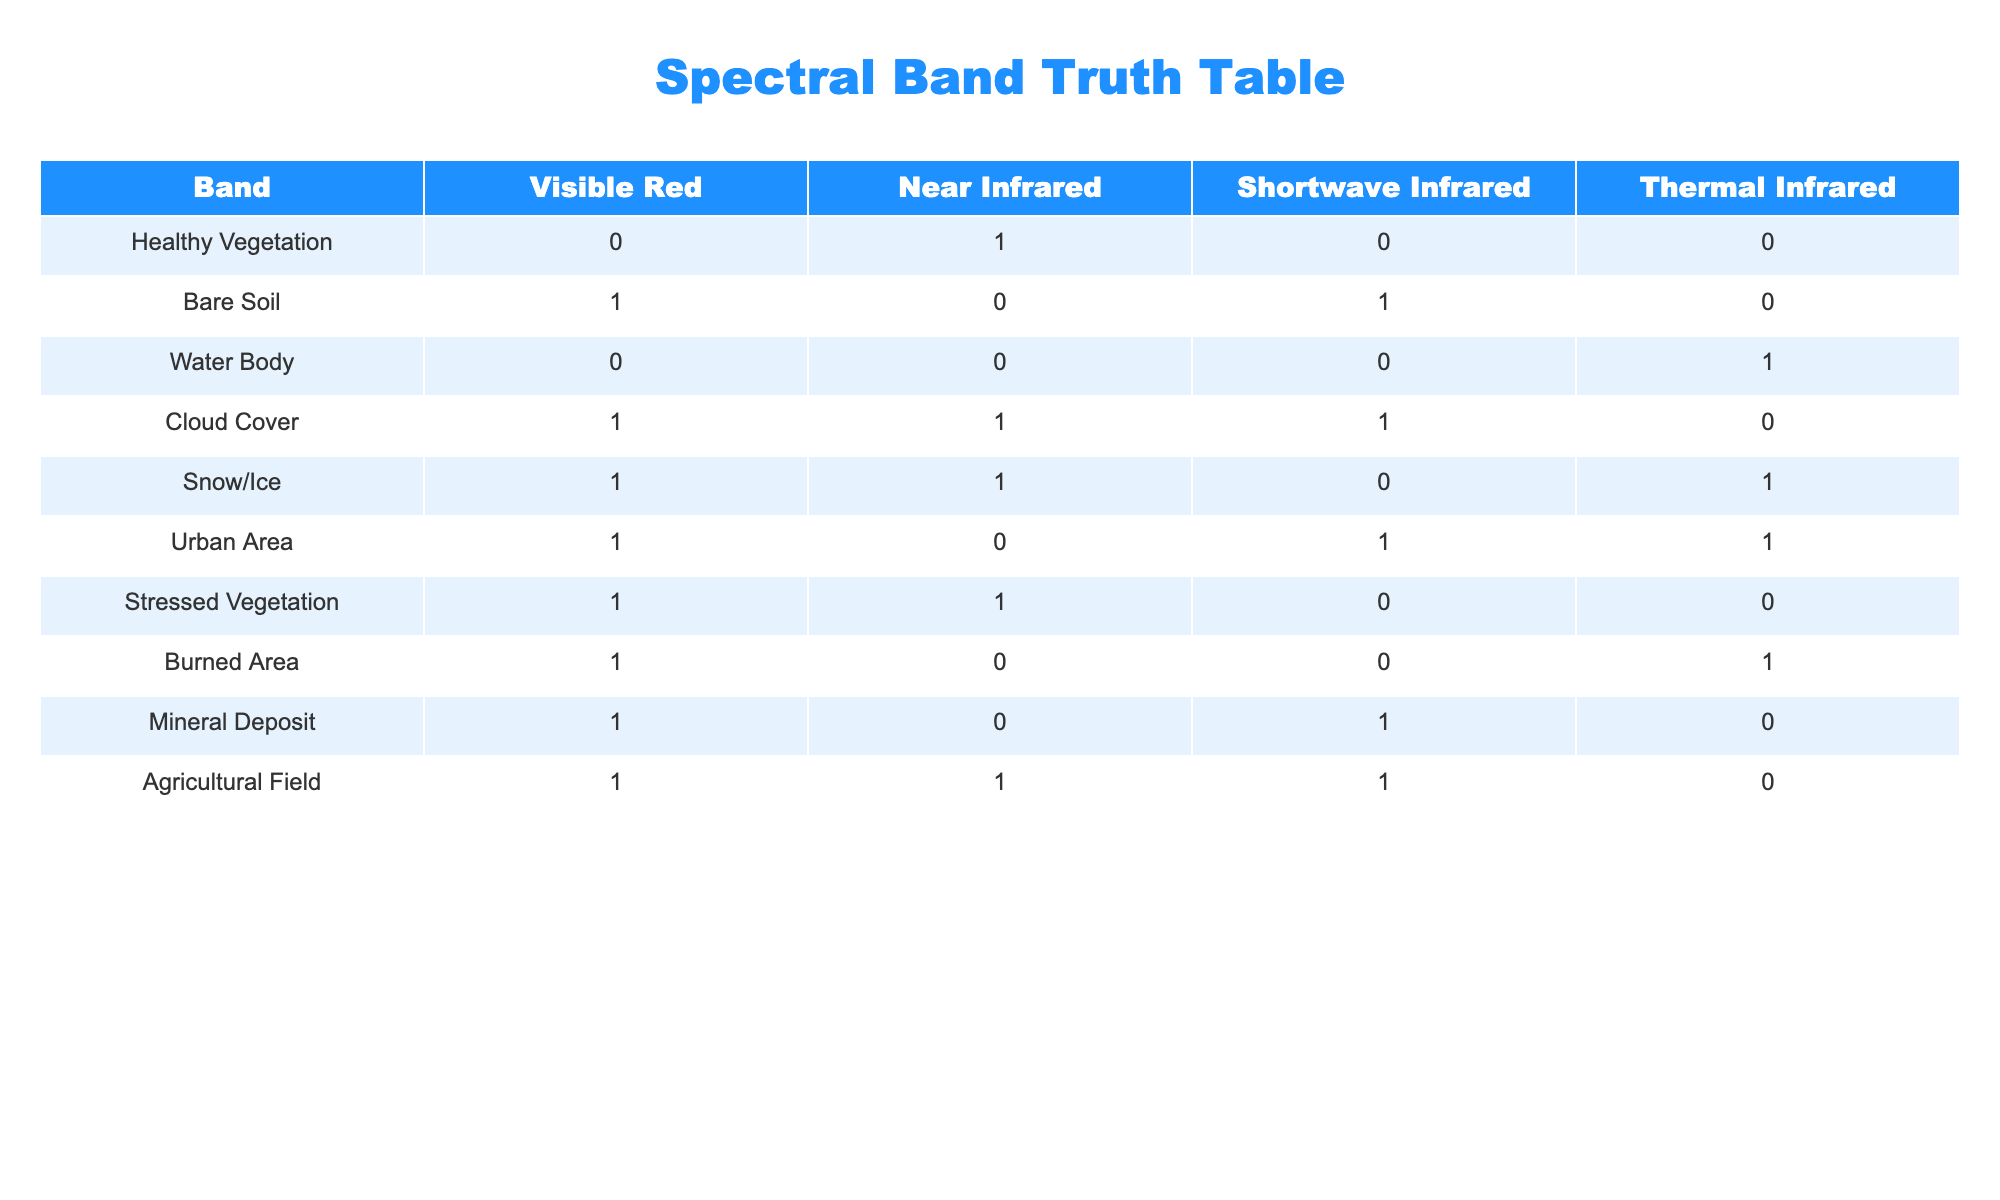What spectral band is associated with Healthy Vegetation? In the row for Healthy Vegetation, the values are as follows: Visible Red = 0, Near Infrared = 1, Shortwave Infrared = 0, Thermal Infrared = 0. Thus, the Near Infrared band is associated with Healthy Vegetation.
Answer: Near Infrared How many classes indicate a value of 1 in the Near Infrared band? By examining the Near Infrared column, the classes with a value of 1 are Healthy Vegetation, Cloud Cover, Stressed Vegetation, and Agricultural Field. This results in a total of 4 classes.
Answer: 4 Is Snow/Ice classified as having a value of 0 in the Shortwave Infrared band? Referring to the row for Snow/Ice, the Shortwave Infrared value is 0. Therefore, it is classified as having a value of 0 in the Shortwave Infrared band.
Answer: Yes What is the sum of the values for the Urban Area across all spectral bands? The values for Urban Area are: Visible Red = 1, Near Infrared = 0, Shortwave Infrared = 1, Thermal Infrared = 1. Therefore, the sum is calculated as 1 + 0 + 1 + 1 = 3.
Answer: 3 Which classes indicate a presence of both Visible Red and Near Infrared bands? Checking the table, the classes with both Visible Red and Near Infrared equal to 1 are Bare Soil, Cloud Cover, Stressed Vegetation, and Agricultural Field. Thus, there are 4 classes that indicate a presence in both bands.
Answer: 4 Does Burned Area have a value of 1 in the Thermal Infrared band? The row for Burned Area indicates that the Thermal Infrared value is 1. Therefore, it does have a value of 1 in that band.
Answer: Yes What is the average value of the Shortwave Infrared for all classes? The values for Shortwave Infrared are: 0 (Healthy Vegetation), 1 (Bare Soil), 0 (Water Body), 1 (Cloud Cover), 0 (Snow/Ice), 1 (Urban Area), 0 (Stressed Vegetation), 0 (Burned Area), 1 (Mineral Deposit), and 1 (Agricultural Field). The sum is 5 and there are 10 classes, so the average is 5/10 = 0.5.
Answer: 0.5 Which class or classes have the highest representation across all bands? Looking at the band values, the class that has values of 1 in the most columns is Agricultural Field, with a value of 1 in the Visible Red, Near Infrared, and Shortwave Infrared bands, totaling 3. No other class has more than 3 ones across the band columns, so Agricultural Field has the highest representation.
Answer: Agricultural Field Is it true that Cloud Cover has a value of 0 in the Thermal Infrared band? In the row for Cloud Cover, the values indicate 0 in the Thermal Infrared band. Therefore, the statement is false.
Answer: No 